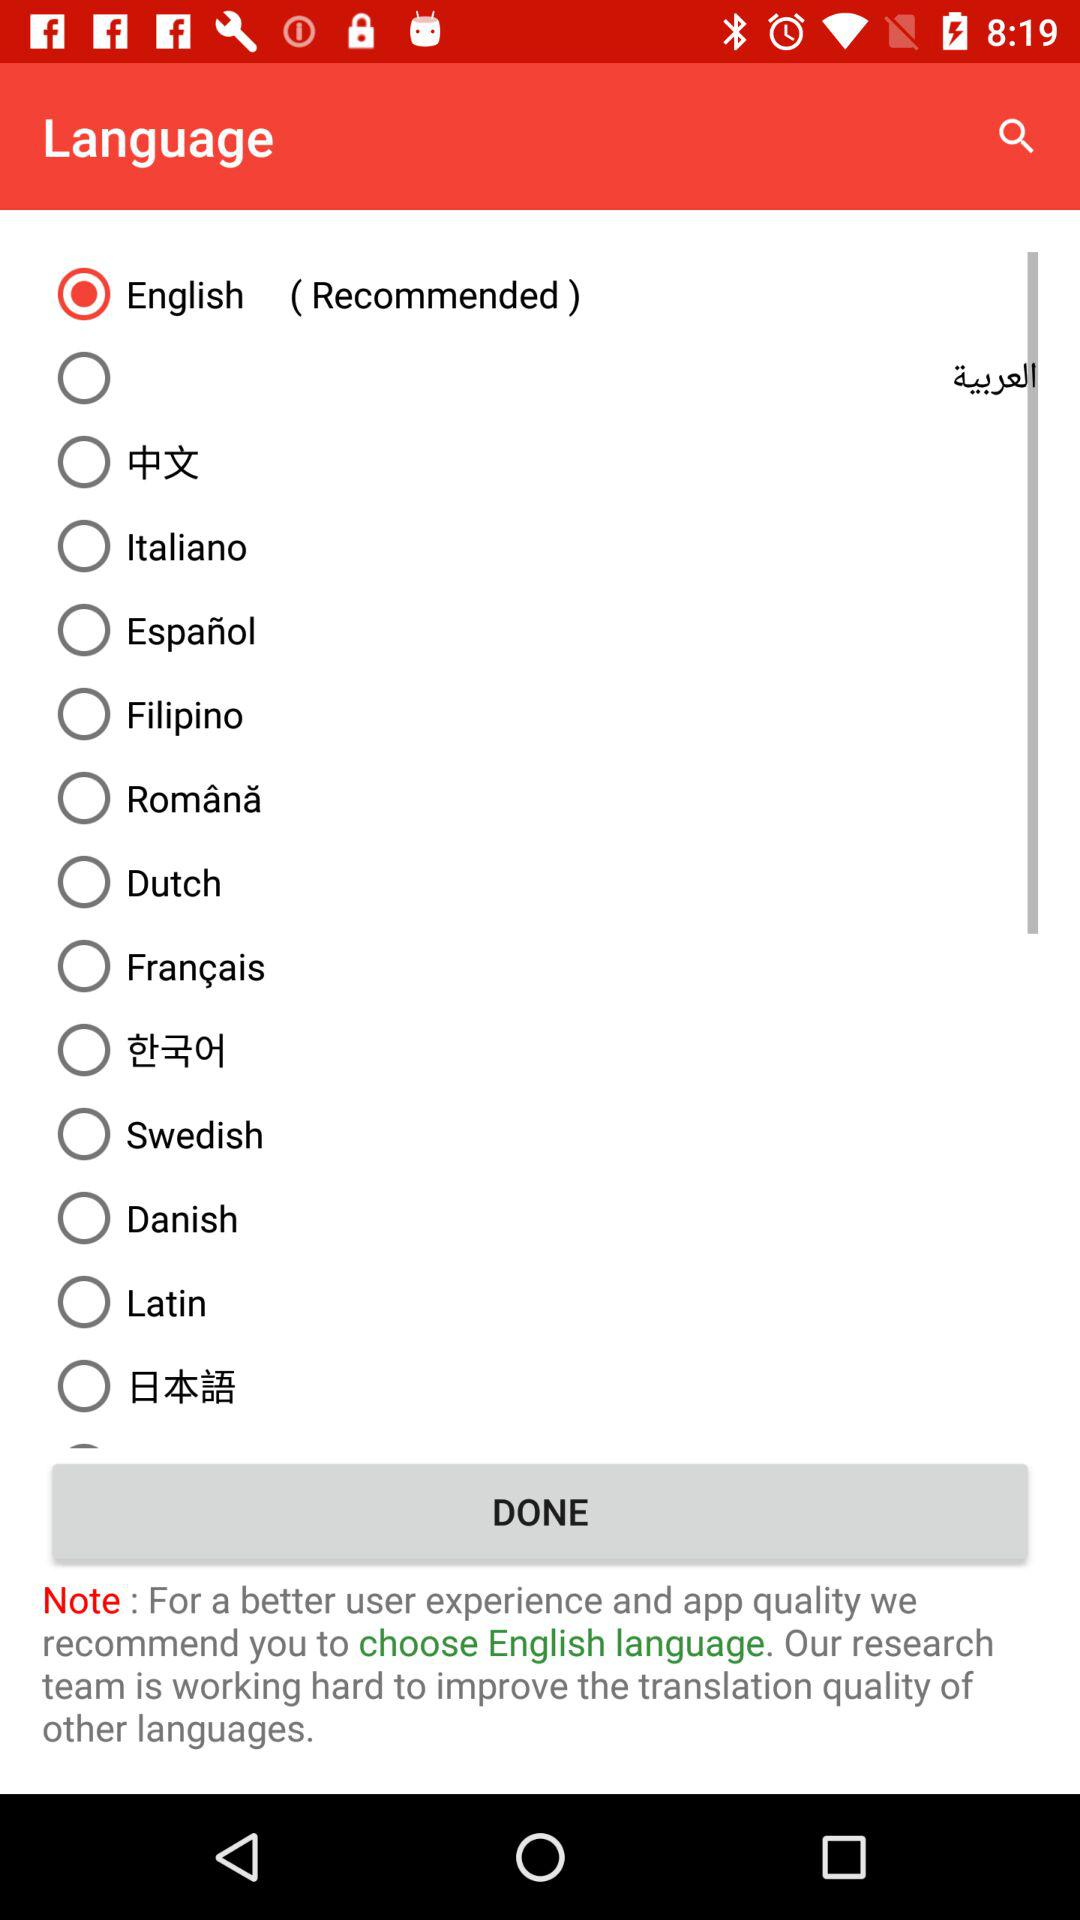Which language is recommended by the app?
Answer the question using a single word or phrase. English 